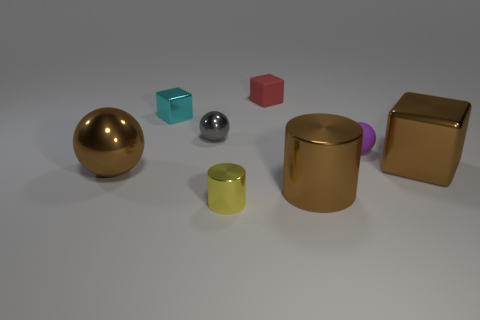Can you describe the spatial arrangement of the objects from left to right? From left to right, the objects are arranged as follows: a large gold-colored sphere, a small teal cube, a small red cube, a small shiny silver sphere, a larger purple cylinder partially behind the gold cylinder, and finally, a large metallic block with a gold tint. 